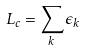Convert formula to latex. <formula><loc_0><loc_0><loc_500><loc_500>L _ { c } = \sum _ { k } \epsilon _ { k }</formula> 